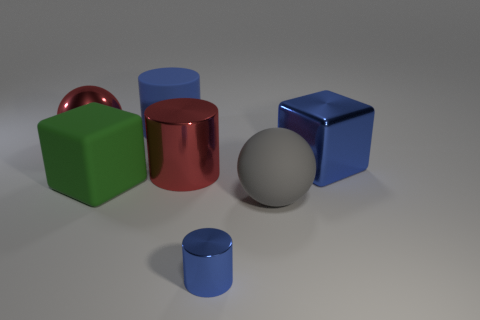There is a shiny thing that is the same color as the metal block; what size is it?
Ensure brevity in your answer.  Small. Are there any big green blocks that have the same material as the large red sphere?
Ensure brevity in your answer.  No. Does the large matte object that is on the left side of the big blue matte cylinder have the same shape as the red shiny thing right of the big matte cylinder?
Provide a short and direct response. No. Is there a brown rubber object?
Your answer should be compact. No. What is the color of the other metal sphere that is the same size as the gray ball?
Make the answer very short. Red. What number of other big objects have the same shape as the gray object?
Ensure brevity in your answer.  1. Are the blue object on the left side of the big shiny cylinder and the large green block made of the same material?
Offer a very short reply. Yes. What number of cylinders are big blue metal objects or metallic objects?
Your response must be concise. 2. What is the shape of the rubber object left of the big cylinder that is behind the block on the right side of the small blue cylinder?
Your answer should be compact. Cube. The shiny thing that is the same color as the big metal cube is what shape?
Your answer should be very brief. Cylinder. 